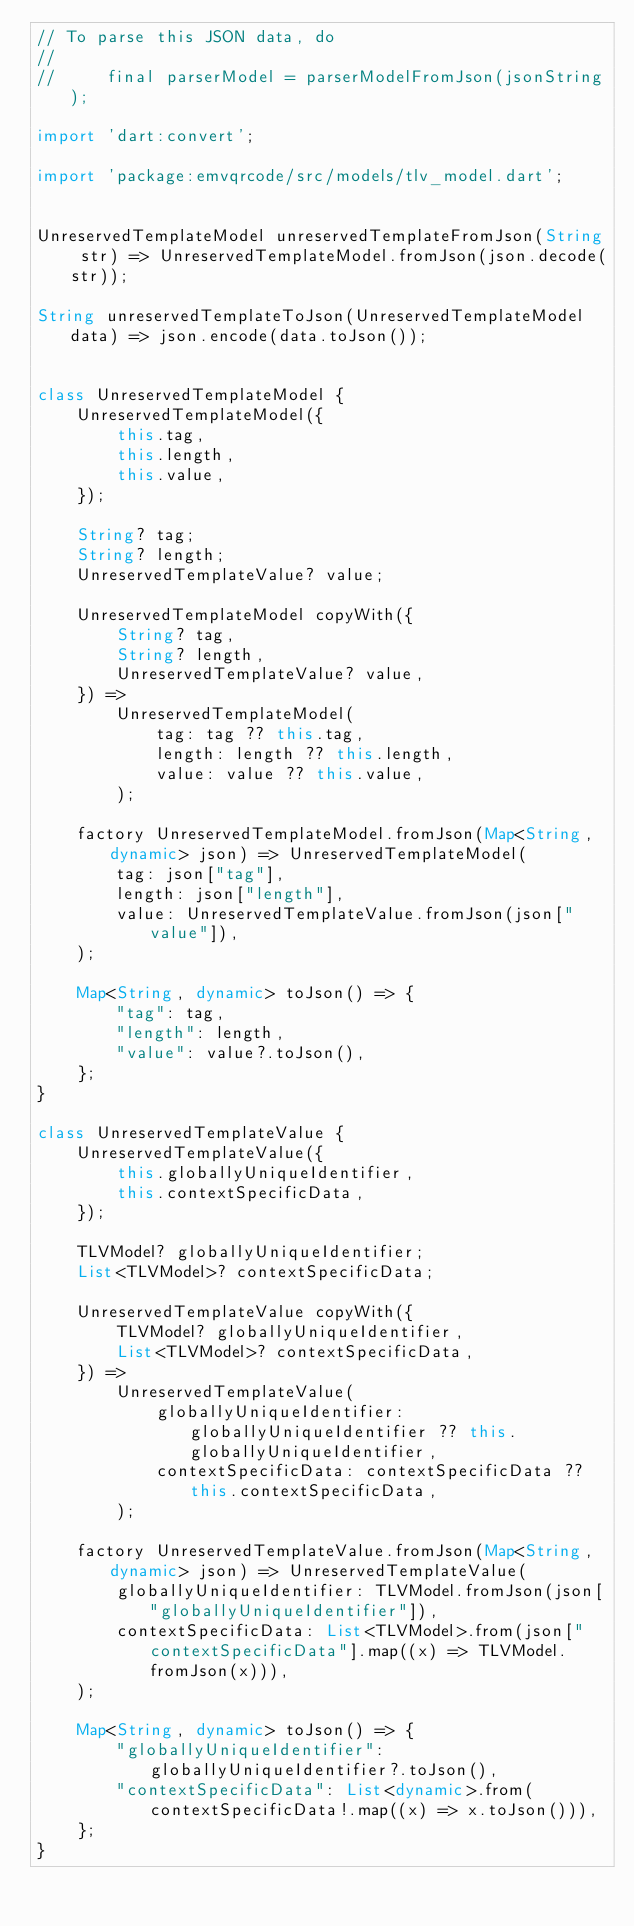Convert code to text. <code><loc_0><loc_0><loc_500><loc_500><_Dart_>// To parse this JSON data, do
//
//     final parserModel = parserModelFromJson(jsonString);

import 'dart:convert';

import 'package:emvqrcode/src/models/tlv_model.dart';


UnreservedTemplateModel unreservedTemplateFromJson(String str) => UnreservedTemplateModel.fromJson(json.decode(str));

String unreservedTemplateToJson(UnreservedTemplateModel data) => json.encode(data.toJson());


class UnreservedTemplateModel {
    UnreservedTemplateModel({
        this.tag,
        this.length,
        this.value,
    });

    String? tag;
    String? length;
    UnreservedTemplateValue? value;

    UnreservedTemplateModel copyWith({
        String? tag,
        String? length,
        UnreservedTemplateValue? value,
    }) => 
        UnreservedTemplateModel(
            tag: tag ?? this.tag,
            length: length ?? this.length,
            value: value ?? this.value,
        );

    factory UnreservedTemplateModel.fromJson(Map<String, dynamic> json) => UnreservedTemplateModel(
        tag: json["tag"],
        length: json["length"],
        value: UnreservedTemplateValue.fromJson(json["value"]),
    );

    Map<String, dynamic> toJson() => {
        "tag": tag,
        "length": length,
        "value": value?.toJson(),
    };
}

class UnreservedTemplateValue {
    UnreservedTemplateValue({
        this.globallyUniqueIdentifier,
        this.contextSpecificData,
    });

    TLVModel? globallyUniqueIdentifier;
    List<TLVModel>? contextSpecificData;

    UnreservedTemplateValue copyWith({
        TLVModel? globallyUniqueIdentifier,
        List<TLVModel>? contextSpecificData,
    }) => 
        UnreservedTemplateValue(
            globallyUniqueIdentifier: globallyUniqueIdentifier ?? this.globallyUniqueIdentifier,
            contextSpecificData: contextSpecificData ?? this.contextSpecificData,
        );

    factory UnreservedTemplateValue.fromJson(Map<String, dynamic> json) => UnreservedTemplateValue(
        globallyUniqueIdentifier: TLVModel.fromJson(json["globallyUniqueIdentifier"]),
        contextSpecificData: List<TLVModel>.from(json["contextSpecificData"].map((x) => TLVModel.fromJson(x))),
    );

    Map<String, dynamic> toJson() => {
        "globallyUniqueIdentifier": globallyUniqueIdentifier?.toJson(),
        "contextSpecificData": List<dynamic>.from(contextSpecificData!.map((x) => x.toJson())),
    };
}
</code> 